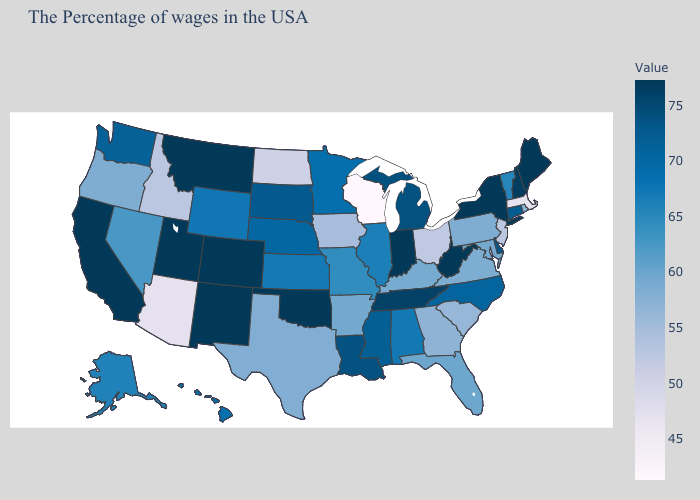Among the states that border Utah , which have the lowest value?
Quick response, please. Arizona. Does New Mexico have the highest value in the USA?
Be succinct. Yes. Among the states that border New Hampshire , does Maine have the highest value?
Keep it brief. Yes. Which states have the lowest value in the Northeast?
Answer briefly. Massachusetts. Does Wisconsin have the lowest value in the USA?
Answer briefly. Yes. Does Massachusetts have a higher value than Nevada?
Concise answer only. No. 